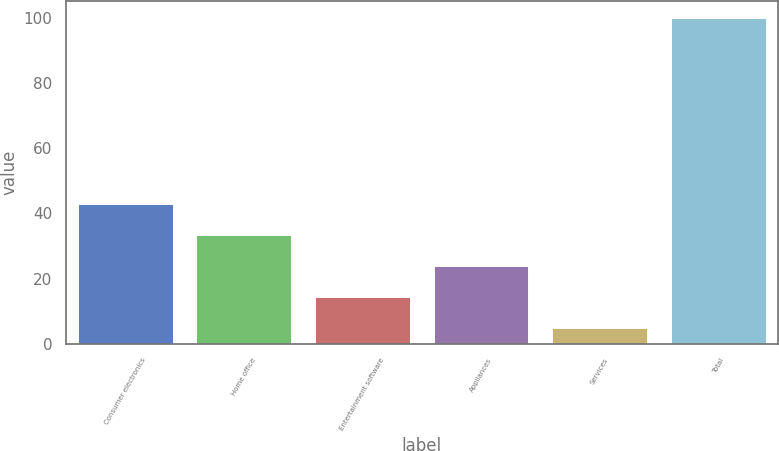Convert chart to OTSL. <chart><loc_0><loc_0><loc_500><loc_500><bar_chart><fcel>Consumer electronics<fcel>Home office<fcel>Entertainment software<fcel>Appliances<fcel>Services<fcel>Total<nl><fcel>43<fcel>33.5<fcel>14.5<fcel>24<fcel>5<fcel>100<nl></chart> 